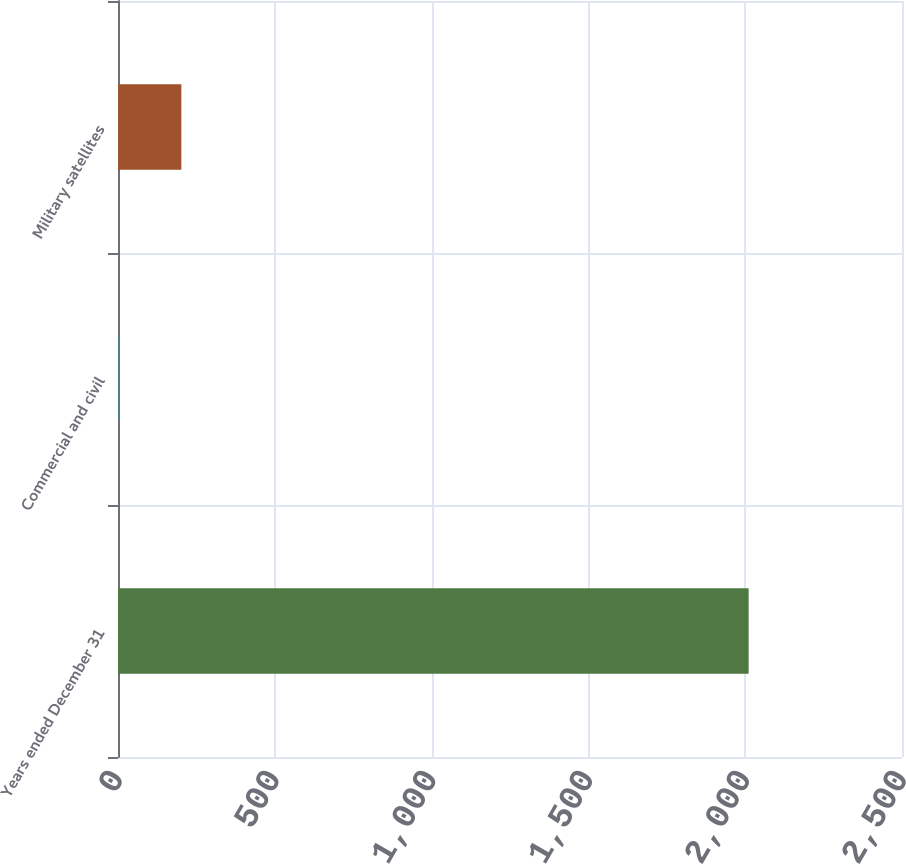Convert chart. <chart><loc_0><loc_0><loc_500><loc_500><bar_chart><fcel>Years ended December 31<fcel>Commercial and civil<fcel>Military satellites<nl><fcel>2011<fcel>1<fcel>202<nl></chart> 